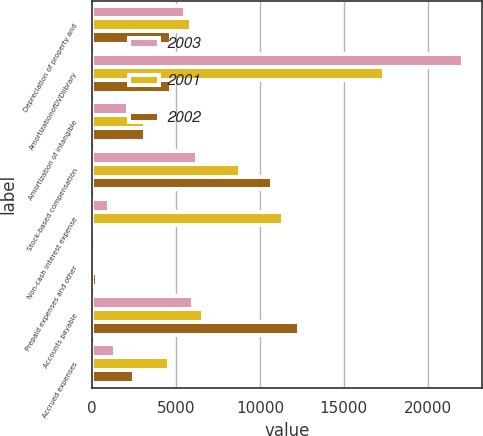Convert chart to OTSL. <chart><loc_0><loc_0><loc_500><loc_500><stacked_bar_chart><ecel><fcel>Depreciation of property and<fcel>AmortizationofDVDlibrary<fcel>Amortization of intangible<fcel>Stock-based compensation<fcel>Non-cash interest expense<fcel>Prepaid expenses and other<fcel>Accounts payable<fcel>Accrued expenses<nl><fcel>2003<fcel>5507<fcel>22127<fcel>2163<fcel>6250<fcel>1017<fcel>15<fcel>6025<fcel>1375<nl><fcel>2001<fcel>5919<fcel>17417<fcel>3141<fcel>8832<fcel>11384<fcel>44<fcel>6635<fcel>4558<nl><fcel>2002<fcel>4720<fcel>4720<fcel>3146<fcel>10719<fcel>103<fcel>290<fcel>12304<fcel>2523<nl></chart> 